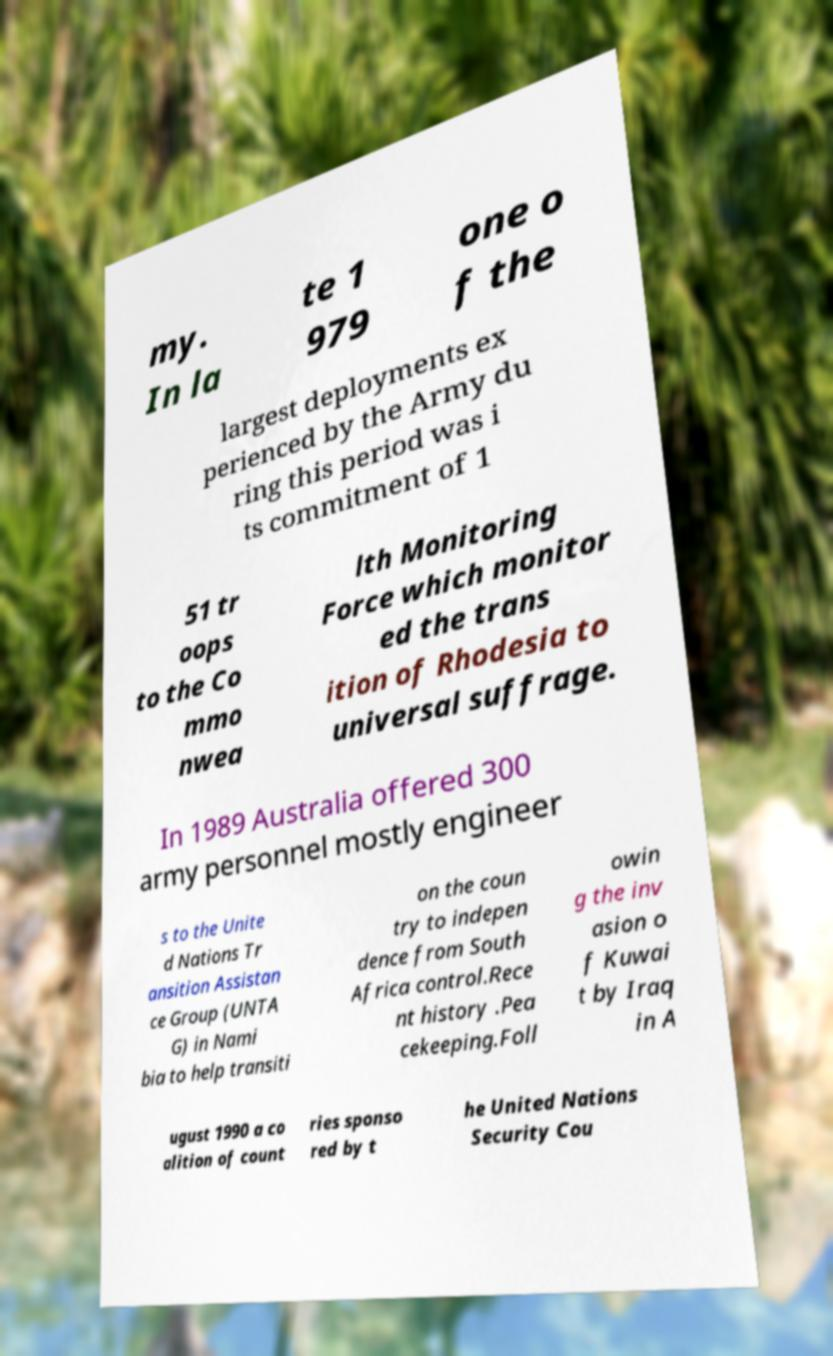I need the written content from this picture converted into text. Can you do that? my. In la te 1 979 one o f the largest deployments ex perienced by the Army du ring this period was i ts commitment of 1 51 tr oops to the Co mmo nwea lth Monitoring Force which monitor ed the trans ition of Rhodesia to universal suffrage. In 1989 Australia offered 300 army personnel mostly engineer s to the Unite d Nations Tr ansition Assistan ce Group (UNTA G) in Nami bia to help transiti on the coun try to indepen dence from South Africa control.Rece nt history .Pea cekeeping.Foll owin g the inv asion o f Kuwai t by Iraq in A ugust 1990 a co alition of count ries sponso red by t he United Nations Security Cou 